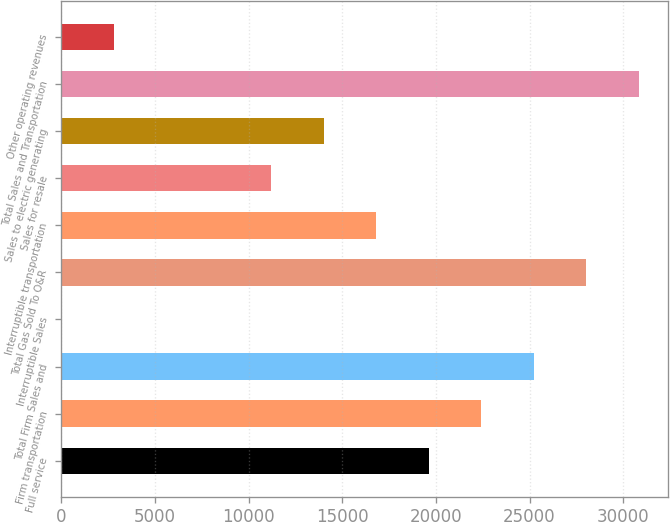Convert chart to OTSL. <chart><loc_0><loc_0><loc_500><loc_500><bar_chart><fcel>Full service<fcel>Firm transportation<fcel>Total Firm Sales and<fcel>Interruptible Sales<fcel>Total Gas Sold To O&R<fcel>Interruptible transportation<fcel>Sales for resale<fcel>Sales to electric generating<fcel>Total Sales and Transportation<fcel>Other operating revenues<nl><fcel>19628.3<fcel>22432.2<fcel>25236.1<fcel>1<fcel>28040<fcel>16824.4<fcel>11216.6<fcel>14020.5<fcel>30843.9<fcel>2804.9<nl></chart> 